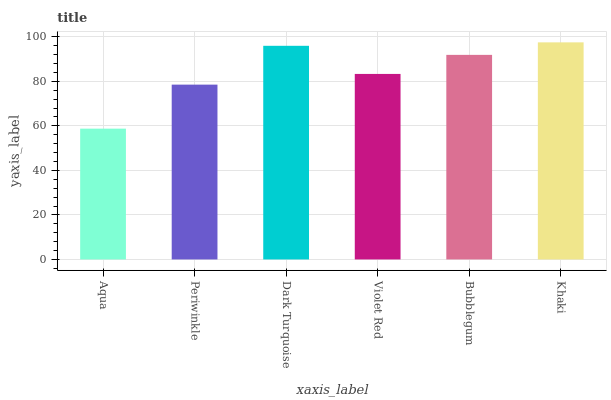Is Aqua the minimum?
Answer yes or no. Yes. Is Khaki the maximum?
Answer yes or no. Yes. Is Periwinkle the minimum?
Answer yes or no. No. Is Periwinkle the maximum?
Answer yes or no. No. Is Periwinkle greater than Aqua?
Answer yes or no. Yes. Is Aqua less than Periwinkle?
Answer yes or no. Yes. Is Aqua greater than Periwinkle?
Answer yes or no. No. Is Periwinkle less than Aqua?
Answer yes or no. No. Is Bubblegum the high median?
Answer yes or no. Yes. Is Violet Red the low median?
Answer yes or no. Yes. Is Violet Red the high median?
Answer yes or no. No. Is Dark Turquoise the low median?
Answer yes or no. No. 